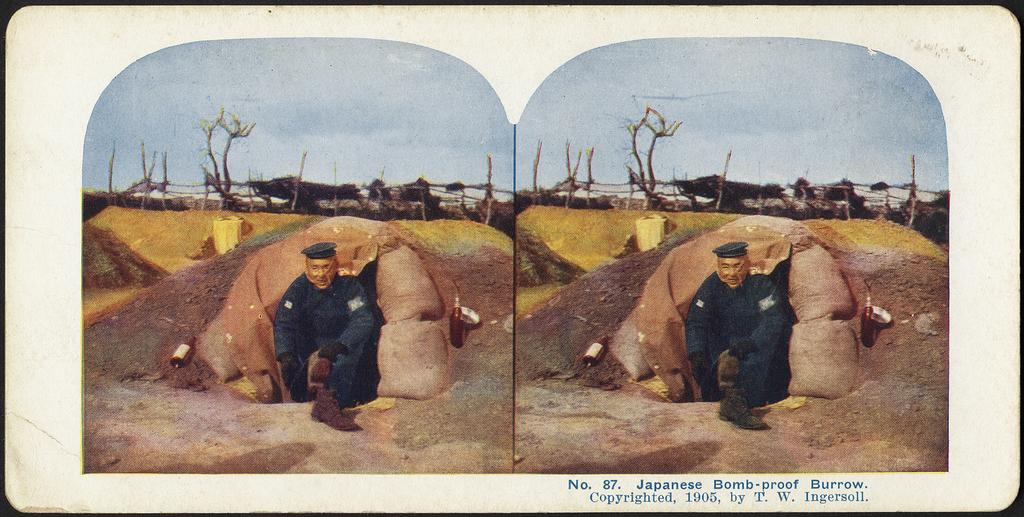What is the main subject of the image? There is a depiction picture in the image. Is the picture the same on both sides of the image? Yes, the same picture appears on both sides of the image. Where can text be found in the image? Text is written on the bottom right side of the image. What type of cable is being used to hold the basket in the image? There is no basket or cable present in the image; it only features a depiction picture with text on the bottom right side. 